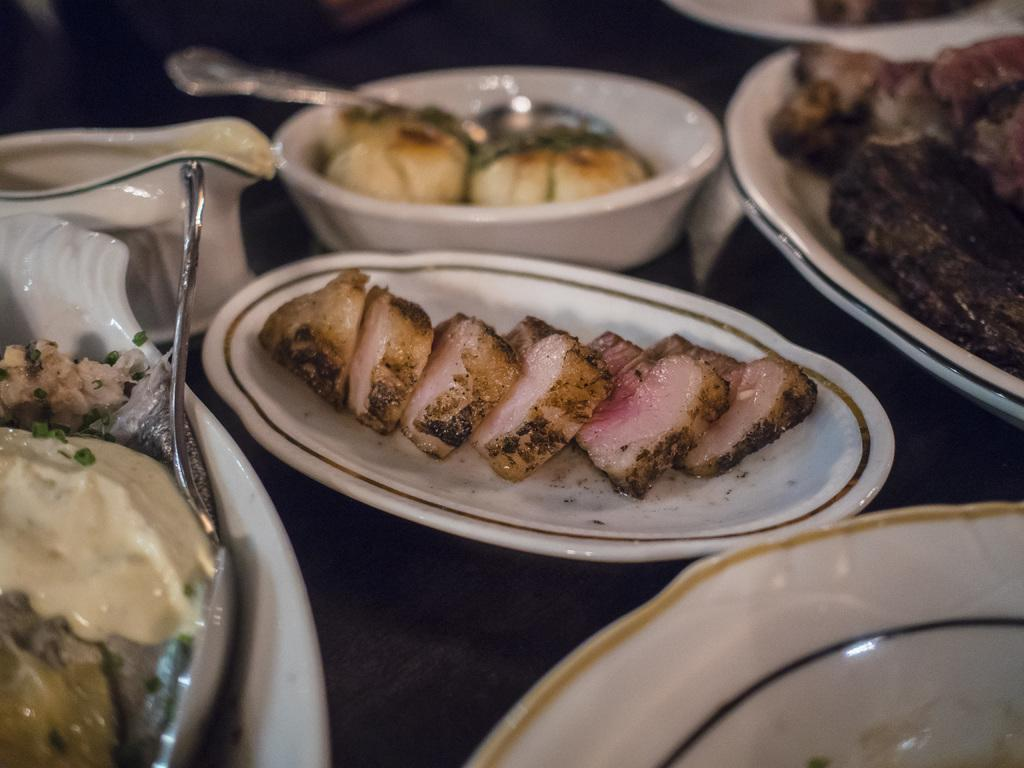What is present on the plates in the image? There is food on plates in the image. Where is the food located in the image? The food is in the center of the image. What type of whistle can be heard in the background of the image? There is no whistle or background noise present in the image, as it is a still image. 